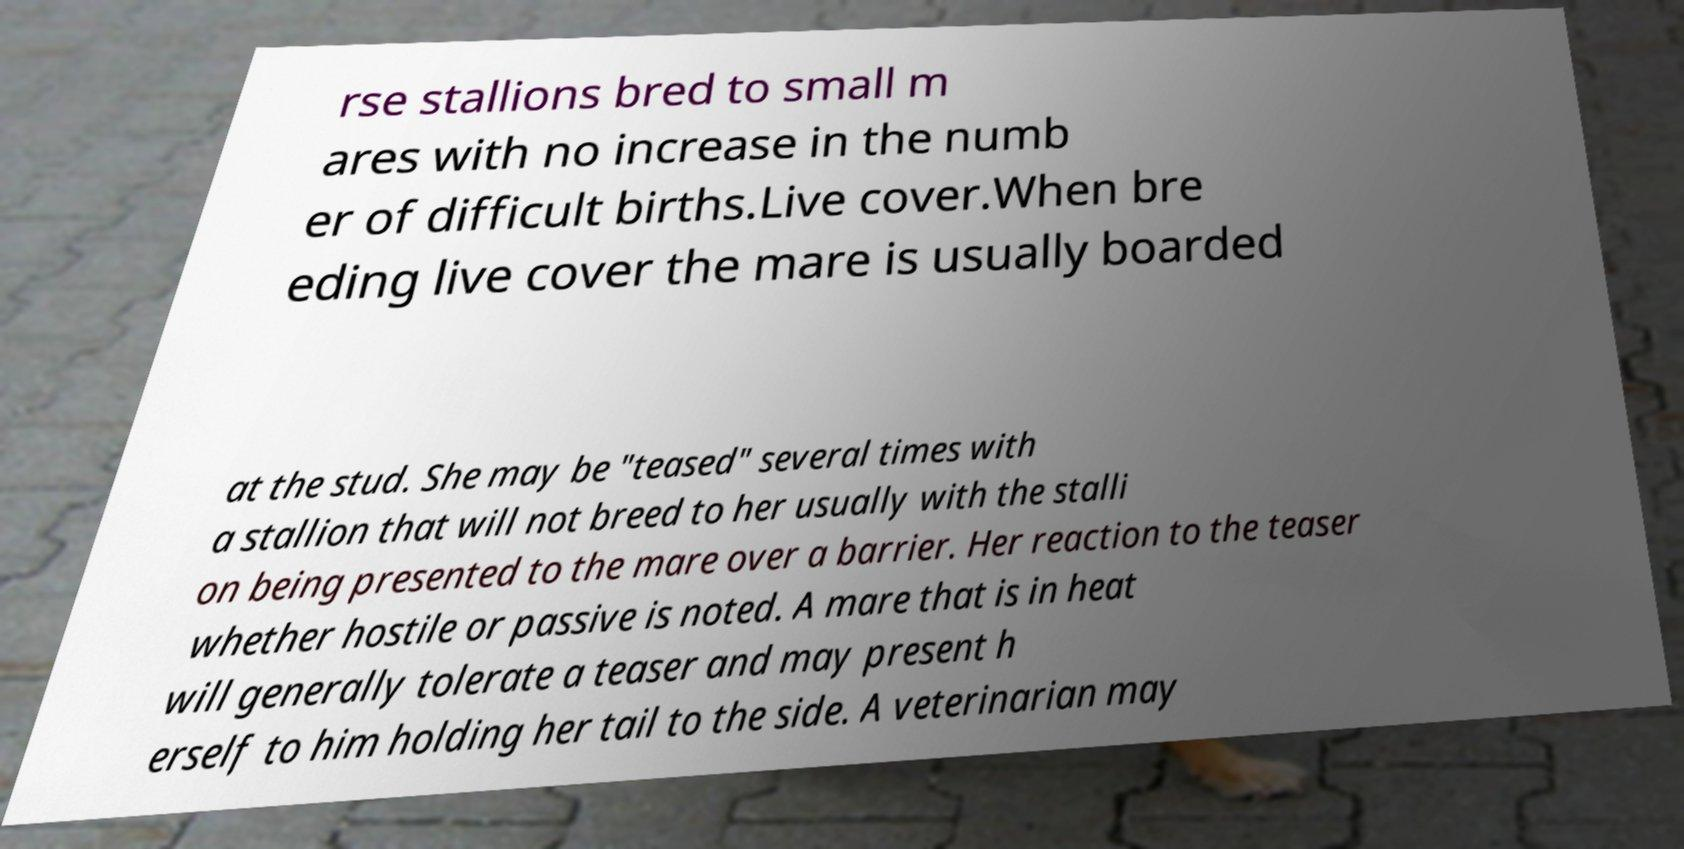What messages or text are displayed in this image? I need them in a readable, typed format. rse stallions bred to small m ares with no increase in the numb er of difficult births.Live cover.When bre eding live cover the mare is usually boarded at the stud. She may be "teased" several times with a stallion that will not breed to her usually with the stalli on being presented to the mare over a barrier. Her reaction to the teaser whether hostile or passive is noted. A mare that is in heat will generally tolerate a teaser and may present h erself to him holding her tail to the side. A veterinarian may 